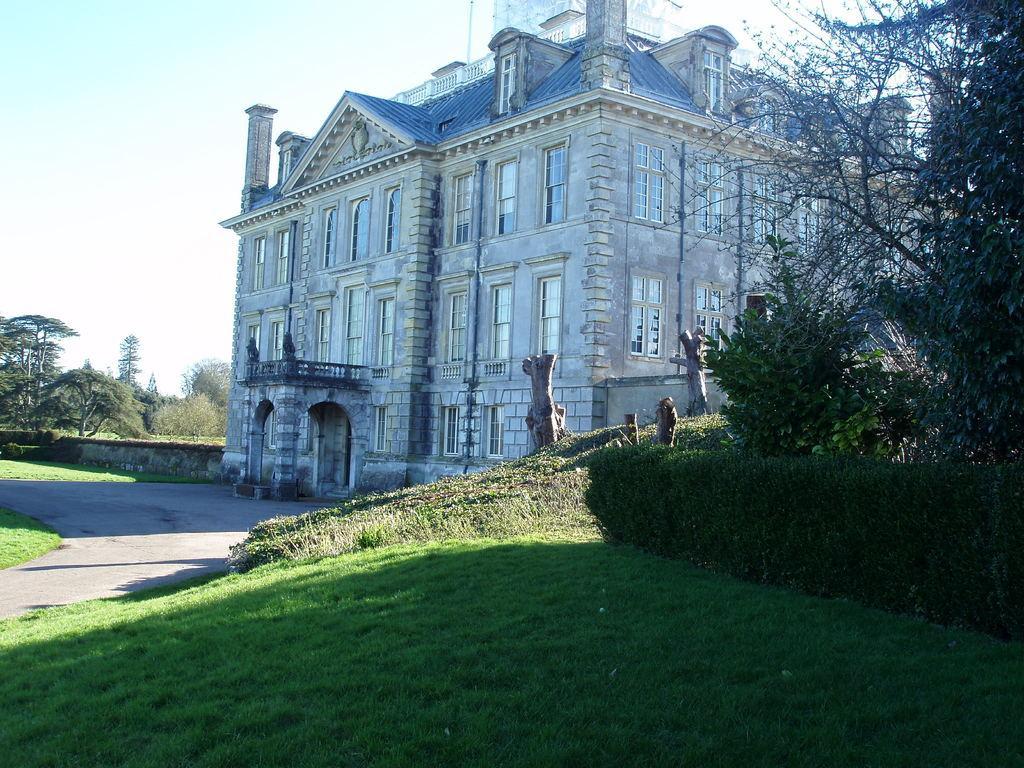How would you summarize this image in a sentence or two? In this picture we can see grass and few trees, and also we can see a building in the middle of the image. 